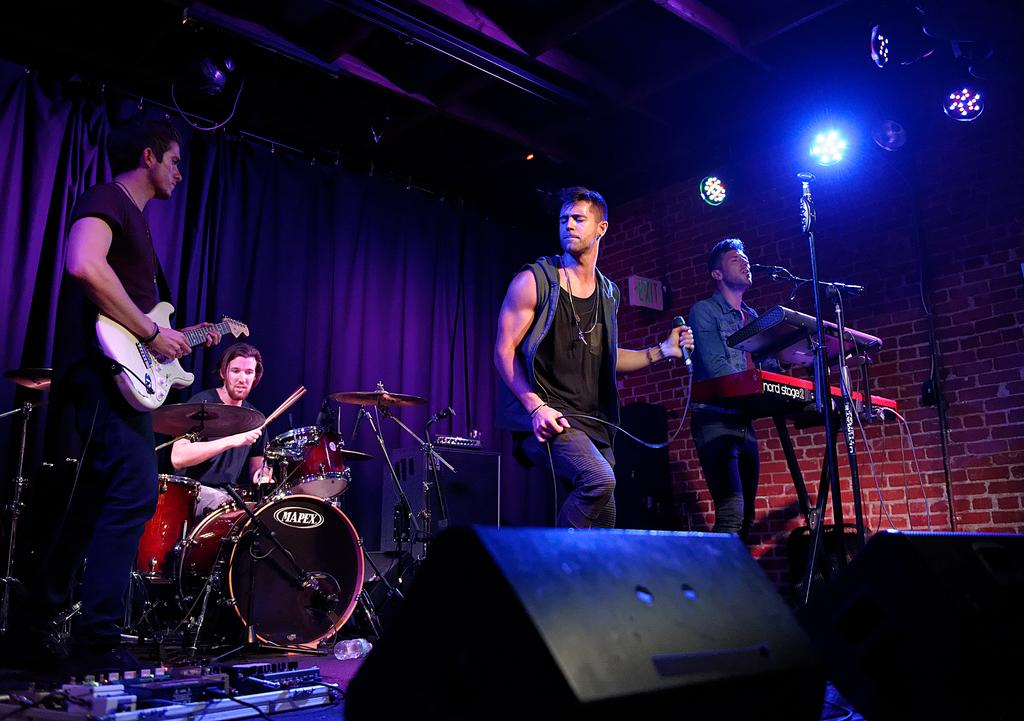How many people are in the image? There are four persons in the image. What are the four persons doing in the image? Each person is playing a musical instrument: drums, guitar, piano, and singing on a mic. What can be seen in the background of the image? There are curtains, lighting, and a wall visible in the background of the image. What type of pear is being used as a prop by the boys in the image? There are no boys or pears present in the image; it features four persons playing musical instruments. What color is the ink used to write on the wall in the image? There is no writing or ink visible on the wall in the image. 